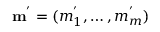Convert formula to latex. <formula><loc_0><loc_0><loc_500><loc_500>m ^ { ^ { \prime } } = ( m _ { 1 } ^ { ^ { \prime } } , \dots , m _ { m } ^ { ^ { \prime } } )</formula> 